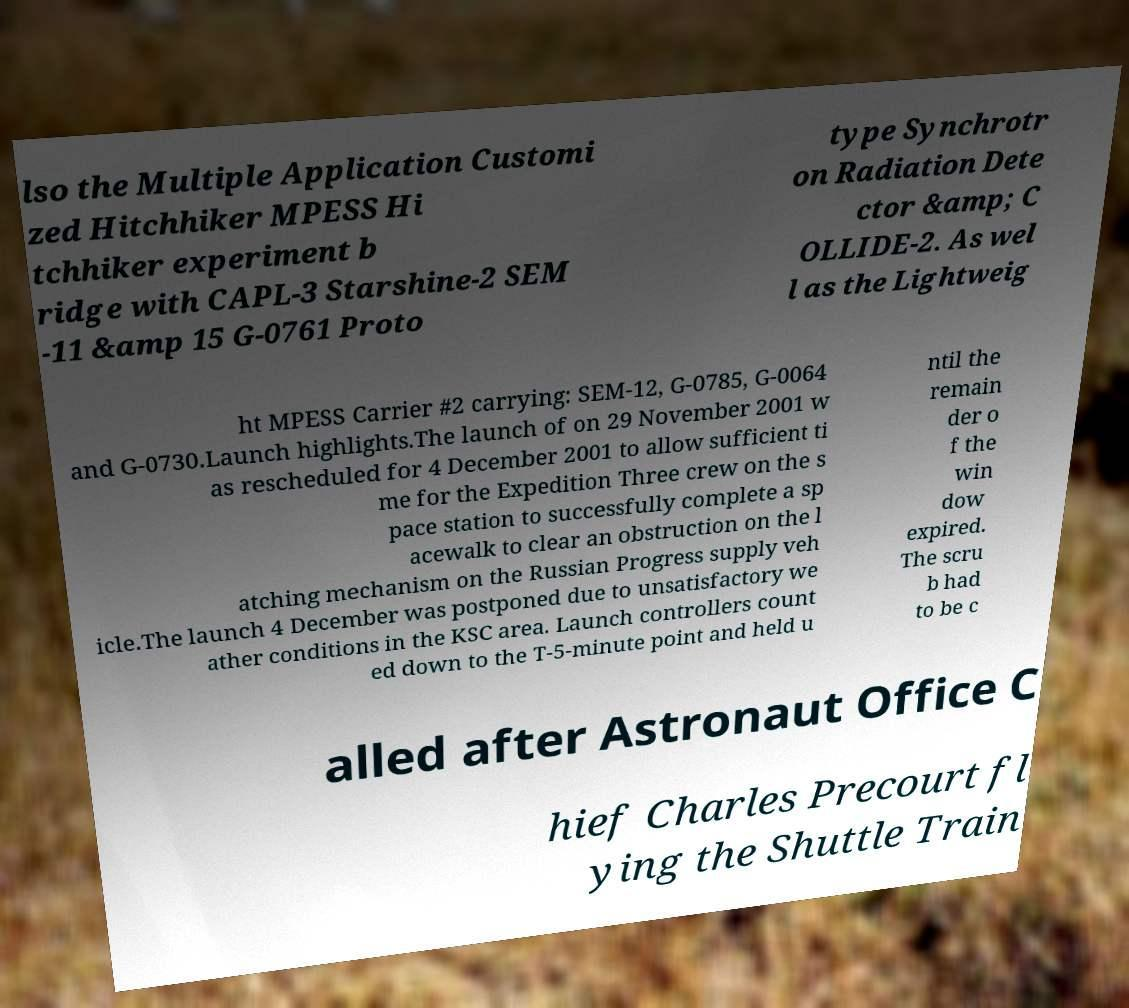Can you read and provide the text displayed in the image?This photo seems to have some interesting text. Can you extract and type it out for me? lso the Multiple Application Customi zed Hitchhiker MPESS Hi tchhiker experiment b ridge with CAPL-3 Starshine-2 SEM -11 &amp 15 G-0761 Proto type Synchrotr on Radiation Dete ctor &amp; C OLLIDE-2. As wel l as the Lightweig ht MPESS Carrier #2 carrying: SEM-12, G-0785, G-0064 and G-0730.Launch highlights.The launch of on 29 November 2001 w as rescheduled for 4 December 2001 to allow sufficient ti me for the Expedition Three crew on the s pace station to successfully complete a sp acewalk to clear an obstruction on the l atching mechanism on the Russian Progress supply veh icle.The launch 4 December was postponed due to unsatisfactory we ather conditions in the KSC area. Launch controllers count ed down to the T-5-minute point and held u ntil the remain der o f the win dow expired. The scru b had to be c alled after Astronaut Office C hief Charles Precourt fl ying the Shuttle Train 